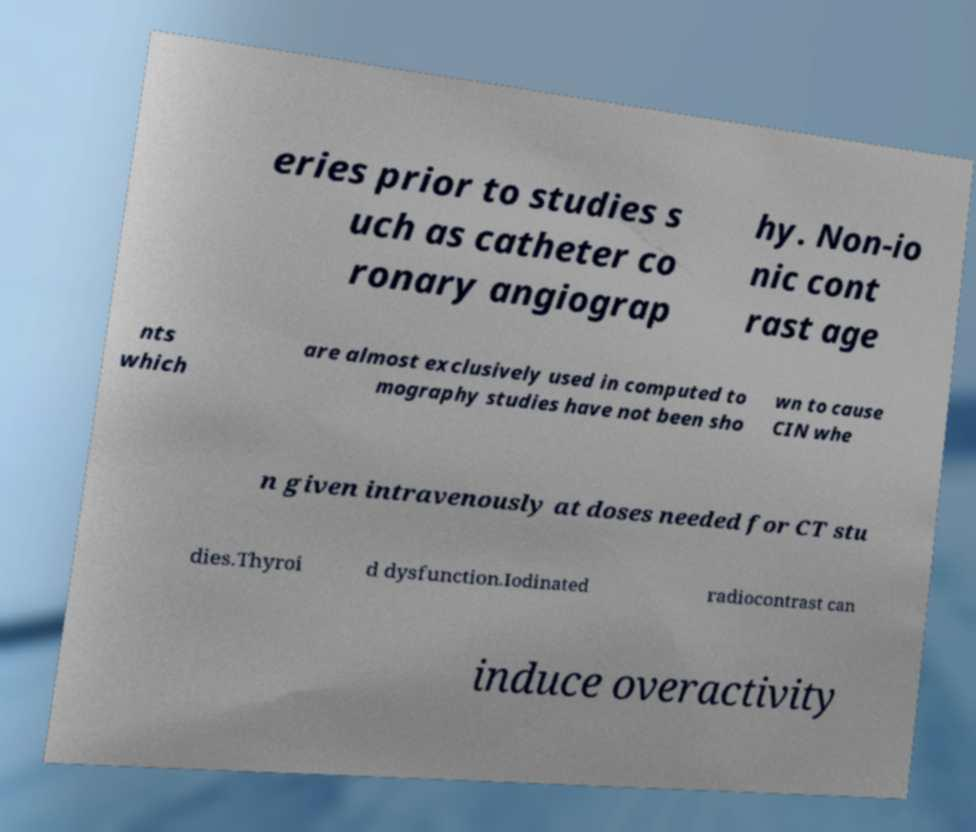Please identify and transcribe the text found in this image. eries prior to studies s uch as catheter co ronary angiograp hy. Non-io nic cont rast age nts which are almost exclusively used in computed to mography studies have not been sho wn to cause CIN whe n given intravenously at doses needed for CT stu dies.Thyroi d dysfunction.Iodinated radiocontrast can induce overactivity 